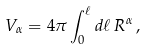Convert formula to latex. <formula><loc_0><loc_0><loc_500><loc_500>V _ { \alpha } = 4 \pi \int _ { 0 } ^ { \ell } d \ell \, R ^ { \alpha } \, ,</formula> 